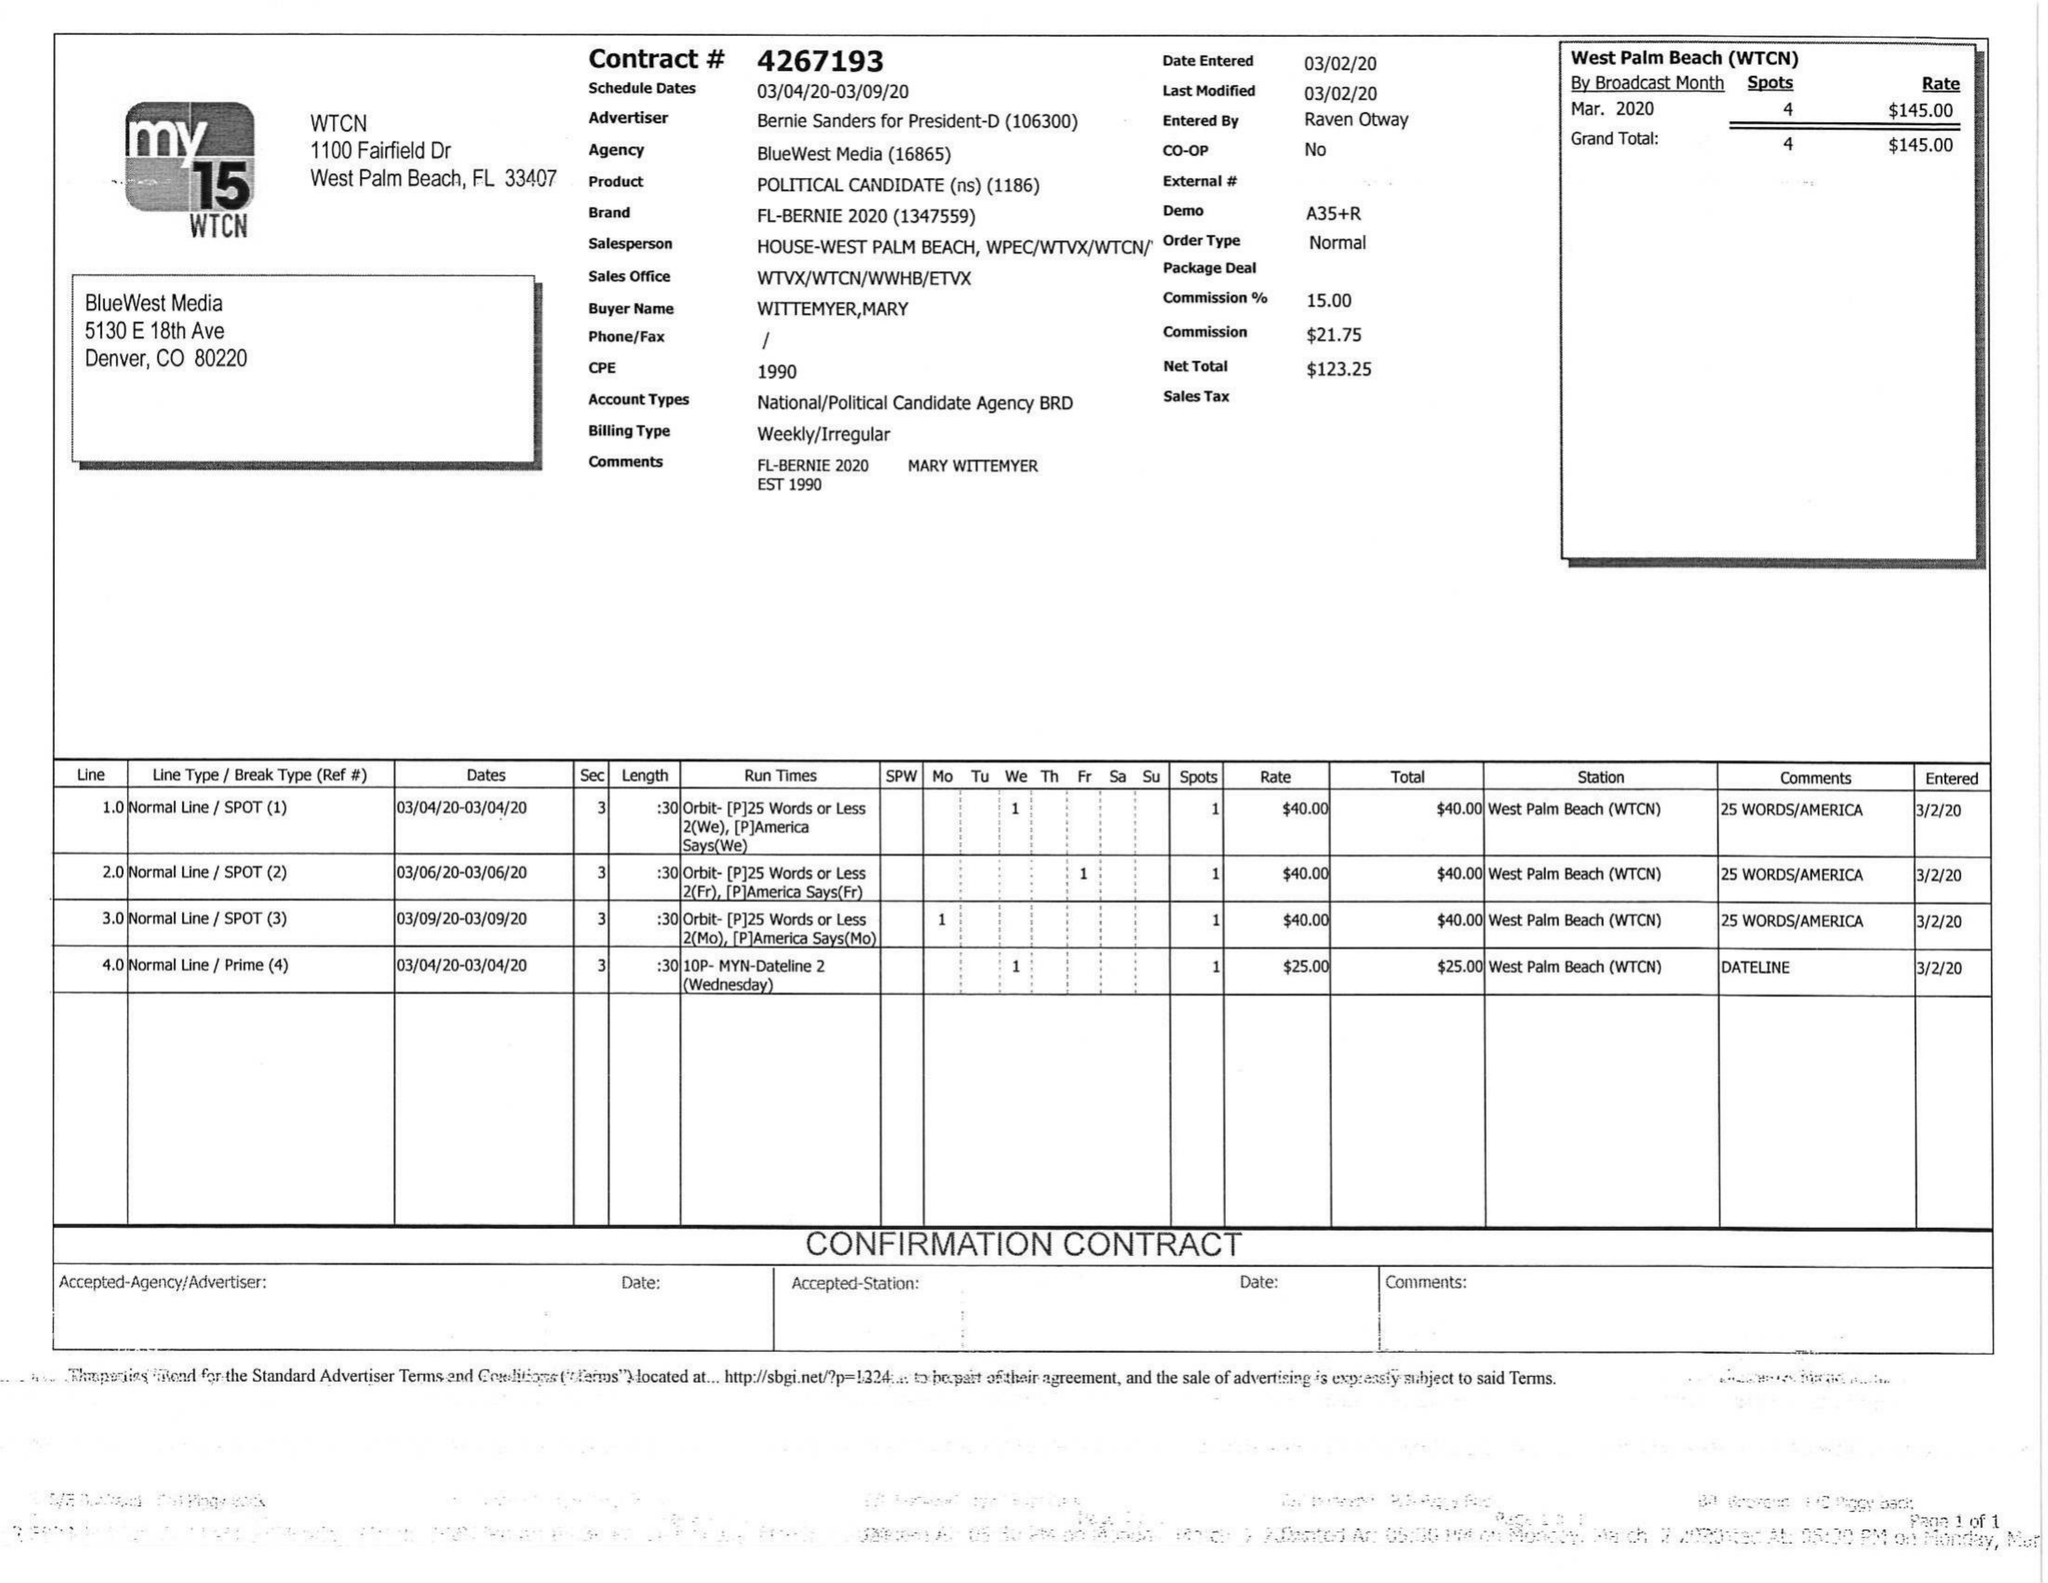What is the value for the gross_amount?
Answer the question using a single word or phrase. 145.00 